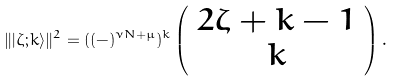Convert formula to latex. <formula><loc_0><loc_0><loc_500><loc_500>\| | \zeta ; k \rangle \| ^ { 2 } = ( ( - ) ^ { \nu N + \mu } ) ^ { k } \left ( \begin{array} { c } 2 \zeta + k - 1 \\ k \end{array} \right ) .</formula> 